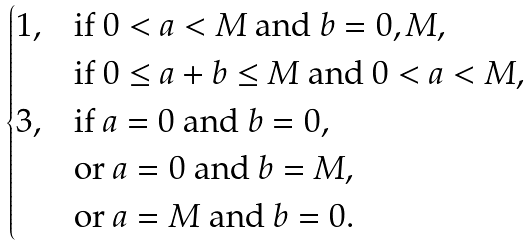<formula> <loc_0><loc_0><loc_500><loc_500>\begin{cases} 1 , & \text {if $0<a<M$ and $b=0,M$,} \\ & \text {if $0\leq a+b\leq M$ and $0<a<M$,} \\ 3 , & \text {if $a=0$ and $b=0$,} \\ & \text {or $a=0$ and $b=M$,} \\ & \text {or $a=M$ and $b=0$.} \end{cases}</formula> 